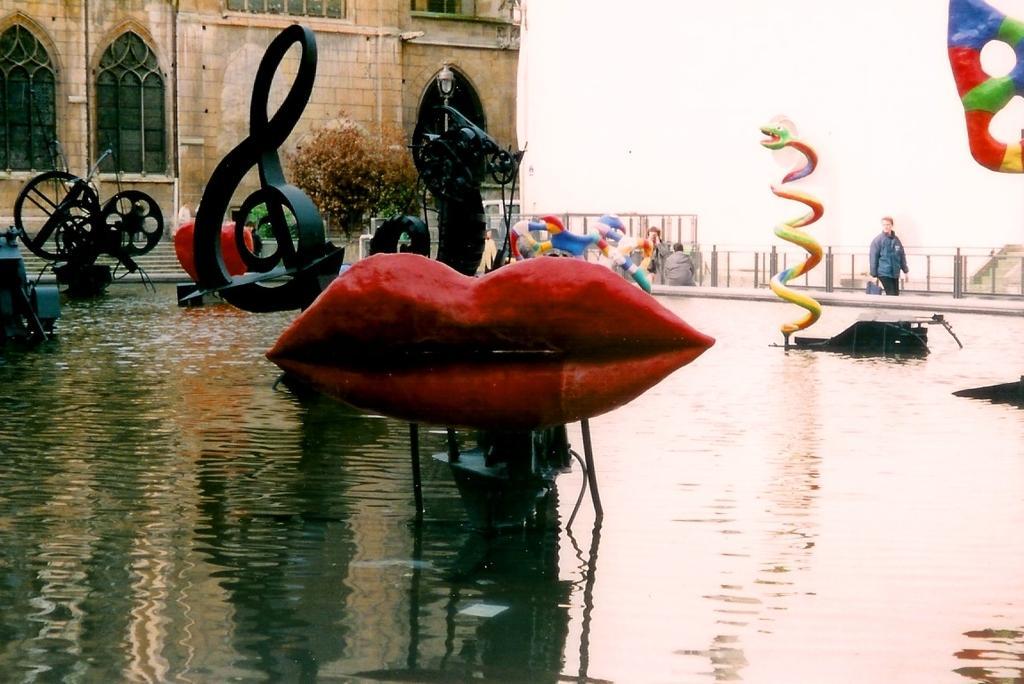Can you describe this image briefly? In the picture there is water, there are many symbols present in the water, there is a tree, there is a building, there are many people present, there is a clear sky. 